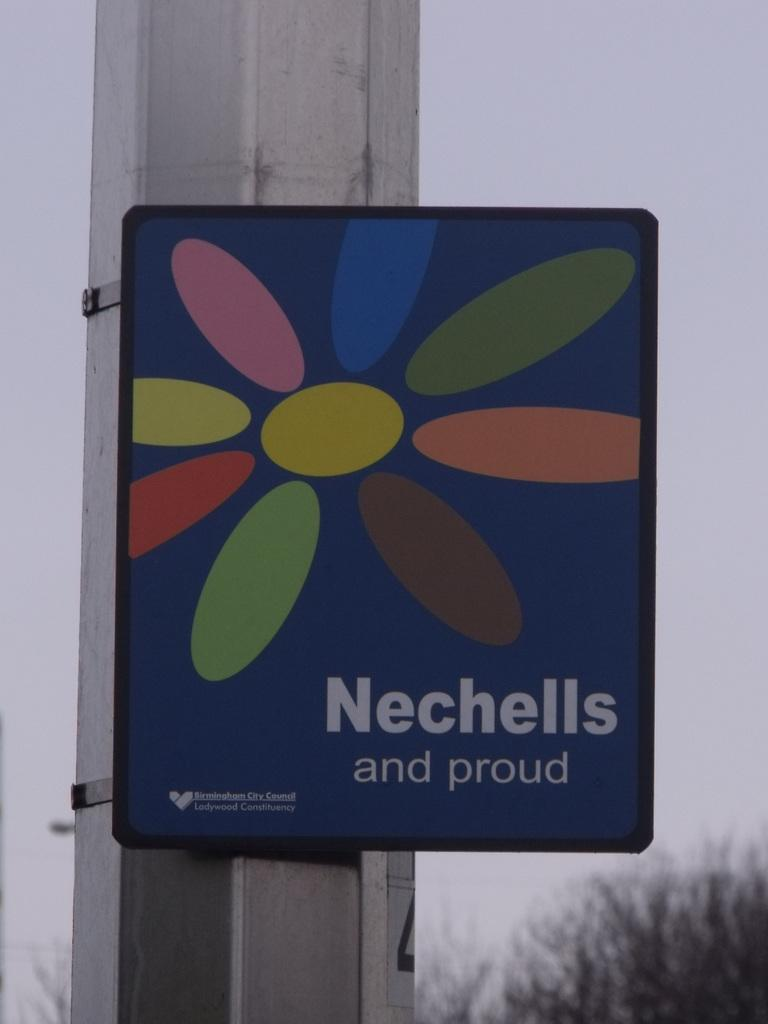<image>
Relay a brief, clear account of the picture shown. A sign installed by the Birmingham City Council reads Nechells and proud. 